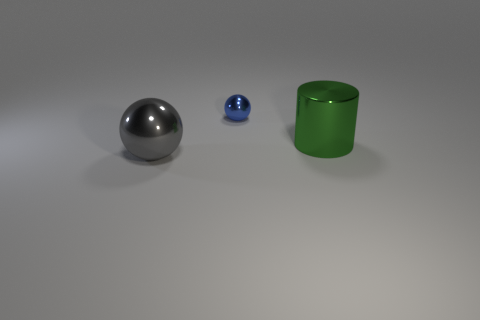Add 3 blue metallic spheres. How many objects exist? 6 Subtract all cylinders. How many objects are left? 2 Add 3 balls. How many balls exist? 5 Subtract 0 brown cubes. How many objects are left? 3 Subtract all small brown objects. Subtract all gray spheres. How many objects are left? 2 Add 1 big gray shiny things. How many big gray shiny things are left? 2 